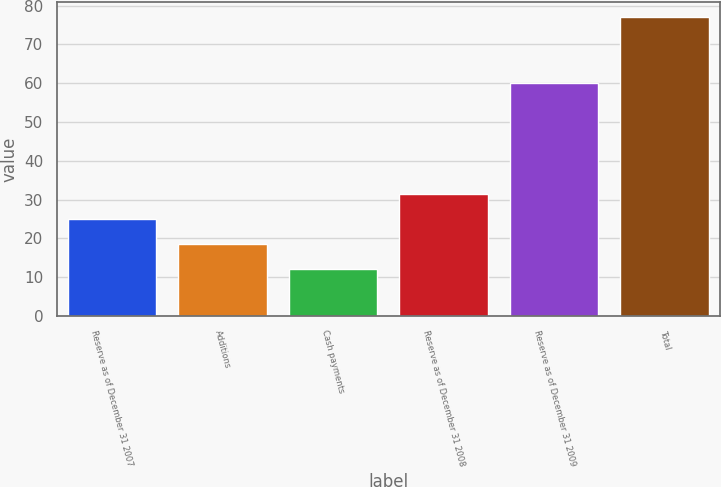Convert chart to OTSL. <chart><loc_0><loc_0><loc_500><loc_500><bar_chart><fcel>Reserve as of December 31 2007<fcel>Additions<fcel>Cash payments<fcel>Reserve as of December 31 2008<fcel>Reserve as of December 31 2009<fcel>Total<nl><fcel>25<fcel>18.5<fcel>12<fcel>31.5<fcel>60<fcel>77<nl></chart> 